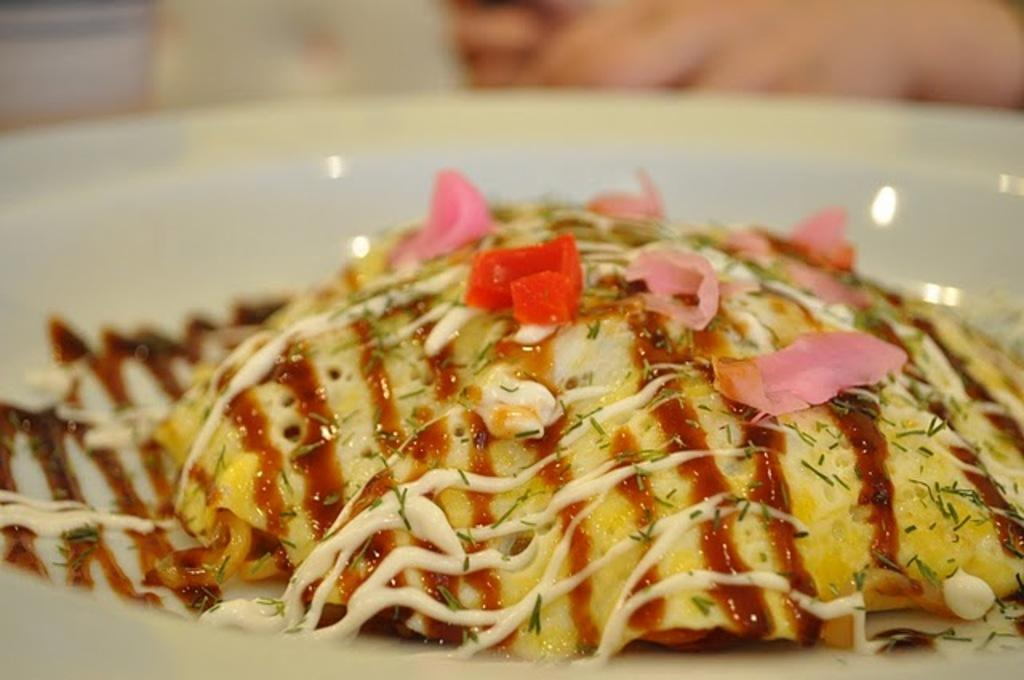What is the main subject of the image? There is a food item in the image. What is the color of the surface on which the food item is placed? The food item is on a white surface. What type of ingredient can be seen in the image? There are grains in the image. How does the mom in the image wash the grains? There is no mom or washing activity present in the image; it only features a food item and grains on a white surface. 